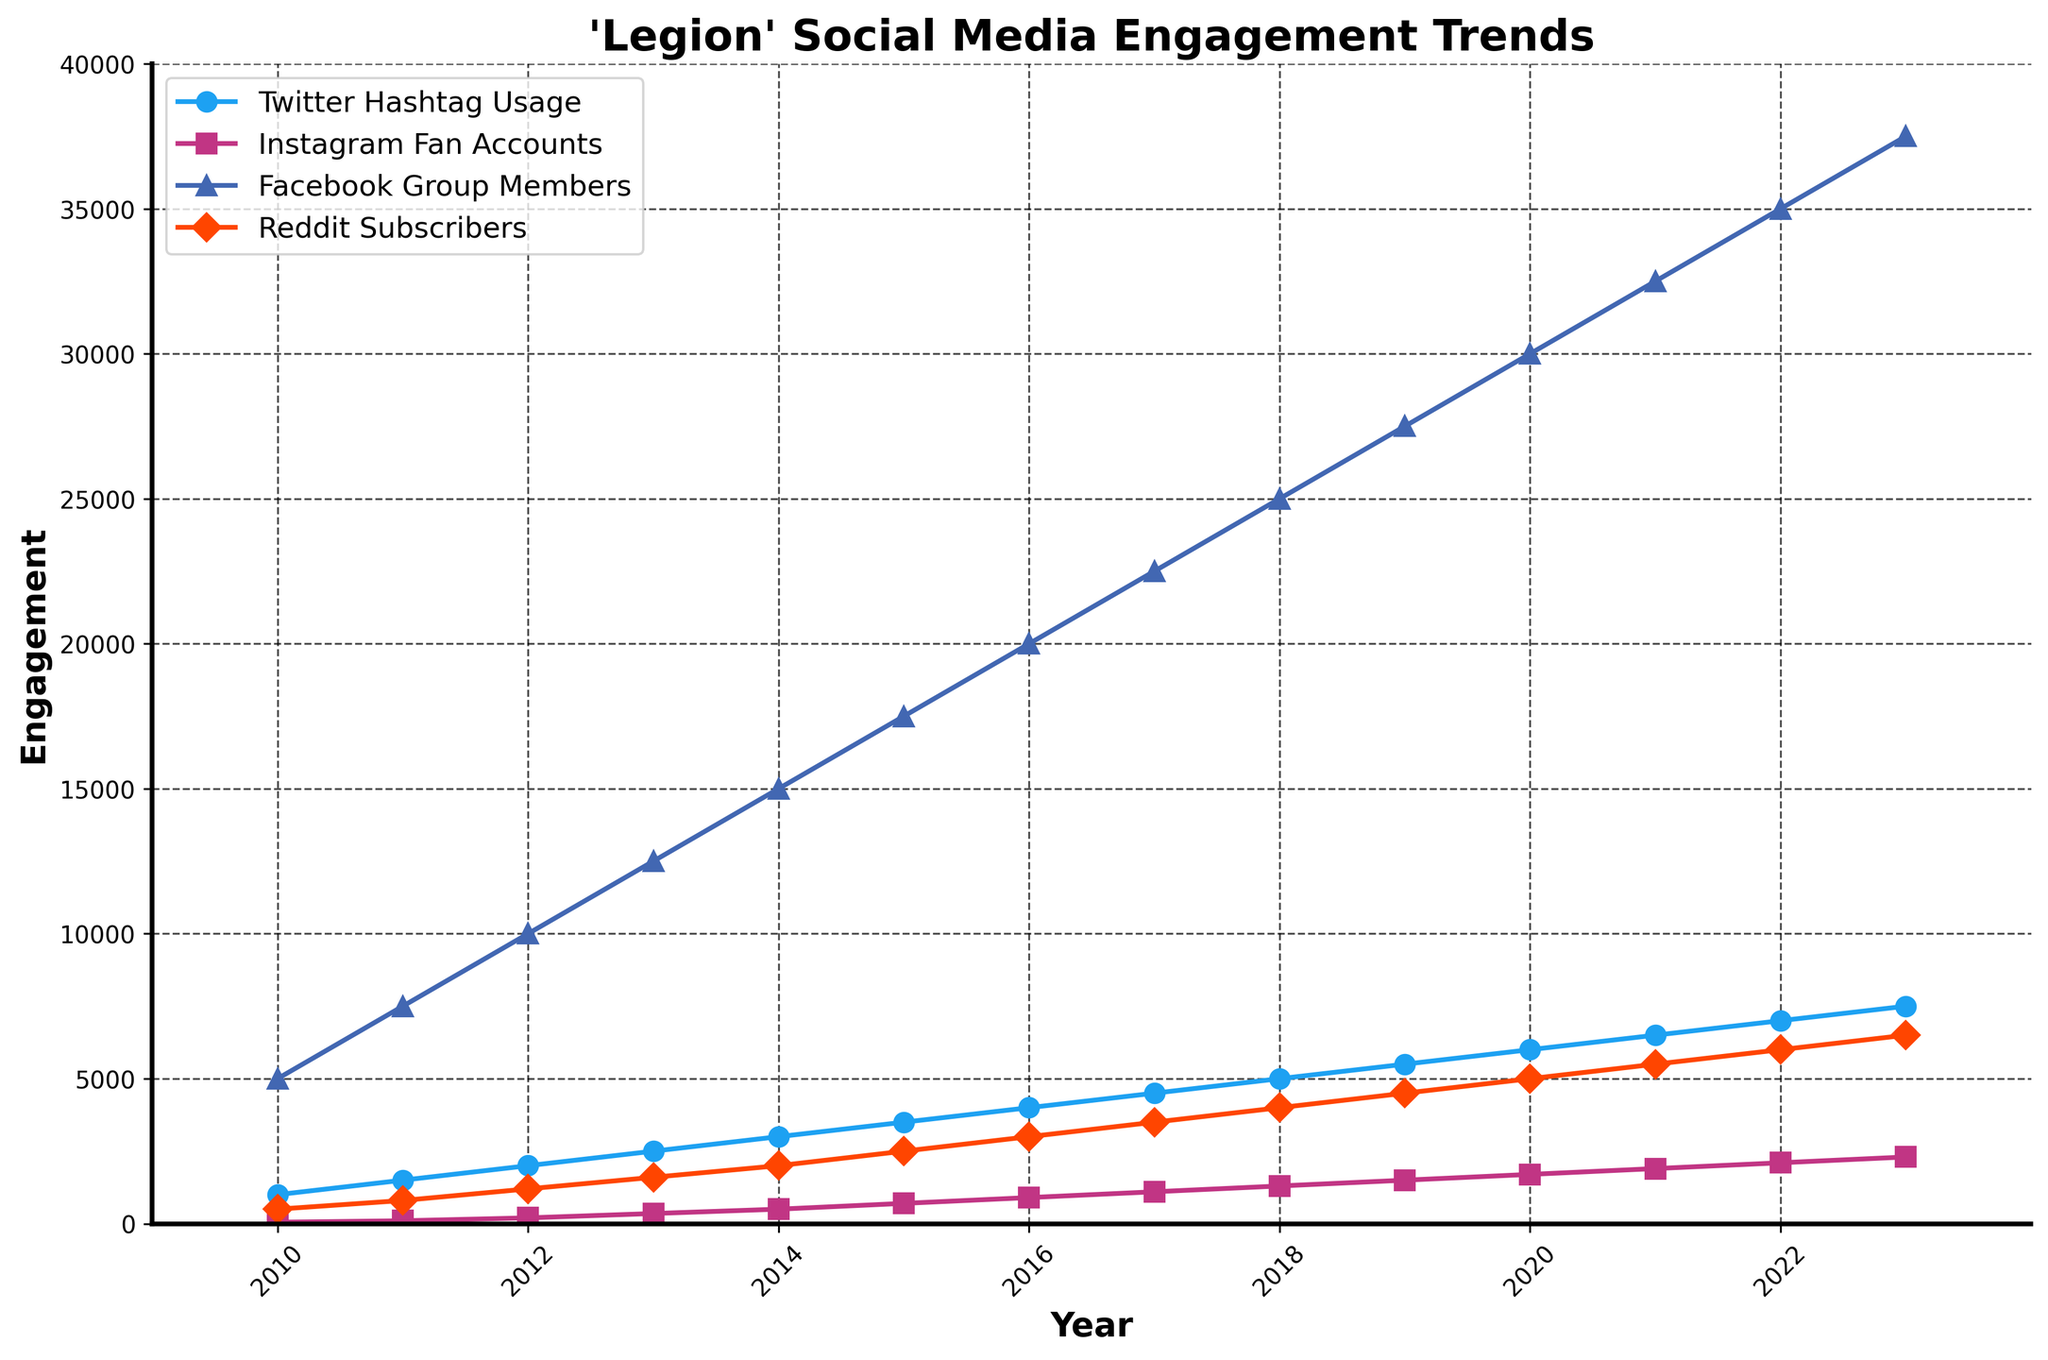What's the trend of Twitter hashtag usage for 'Legion' over the years? To see the trend, examine the line representing Twitter hashtag usage. It consistently increases each year, starting from 1,000 in 2010 and reaching 7,500 by 2023.
Answer: Increasing Which social media platform had the highest engagement in 2019? In 2019, the line corresponding to Facebook Group Members is the highest, indicating it had the most engagement with 27,500 members.
Answer: Facebook Group Members How many Instagram fan accounts were there in 2015? Look at the point corresponding to 2015 for the line representing Instagram fan accounts. In 2015, there were 700 Instagram fan accounts.
Answer: 700 By how much did Reddit subscribers increase from 2010 to 2023? The number of Reddit subscribers in 2010 was 500. In 2023, it was 6,500. Subtracting the 2010 value from the 2023 value, 6,500 - 500 = 6,000.
Answer: 6,000 Which year saw the highest increase in Facebook group members compared to the previous year? Compare the year-over-year increases by looking at the vertical distance between consecutive data points for Facebook Group Members. 2014 to 2015 had the highest increase (from 15,000 to 17,500) = 2,500.
Answer: 2014-2015 What's the average number of Twitter hashtag usages from 2010 to 2023? Sum the Twitter hashtag usages from 2010 to 2023 (1000 + 1500 + 2000 + 2500 + 3000 + 3500 + 4000 + 4500 + 5000 + 5500 + 6000 + 6500 + 7000 + 7500 = 57,000) and divide by the number of years (14). 57,000 / 14 = 4,071.43
Answer: 4,071.43 Between which consecutive years did Instagram fan accounts grow the most? Examine the distances between consecutive data points for Instagram fan accounts. The largest increase occurred between 2012 and 2013 (350 - 200 = 150).
Answer: 2012-2013 How much more engagement did Facebook group members have than Reddit subscribers in 2021? Look at the values for 2021: Facebook Group Members had 32,500 and Reddit Subscribers had 5,500. Subtracting these, 32,500 - 5,500 = 27,000.
Answer: 27,000 What's the median value for the number of Reddit subscribers over the given years? List all the values in ascending order (500, 800, 1200, 1600, 2000, 2500, 3000, 3500, 4000, 4500, 5000, 5500, 6000, 6500). The middle values are 3000 and 3500. Average them to get the median: (3000 + 3500) / 2 = 3,250.
Answer: 3,250 